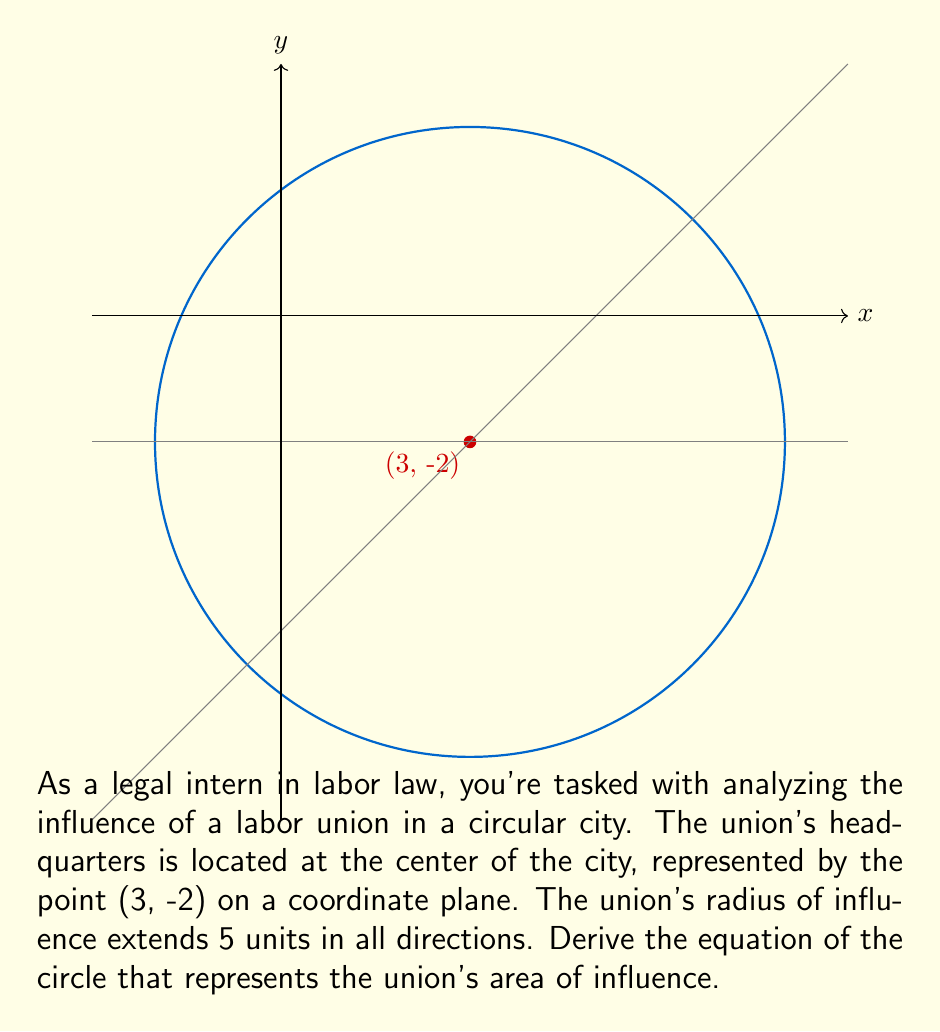Provide a solution to this math problem. To derive the equation of a circle, we use the general form:

$$(x - h)^2 + (y - k)^2 = r^2$$

Where (h, k) is the center of the circle and r is the radius.

Given:
- Center: (3, -2)
- Radius: 5 units

Step 1: Identify the values for h, k, and r.
h = 3
k = -2
r = 5

Step 2: Substitute these values into the general equation.
$$(x - 3)^2 + (y - (-2))^2 = 5^2$$

Step 3: Simplify the equation.
$$(x - 3)^2 + (y + 2)^2 = 25$$

This is the equation of the circle representing the radius of influence for the labor union.
Answer: $$(x - 3)^2 + (y + 2)^2 = 25$$ 